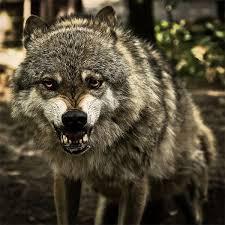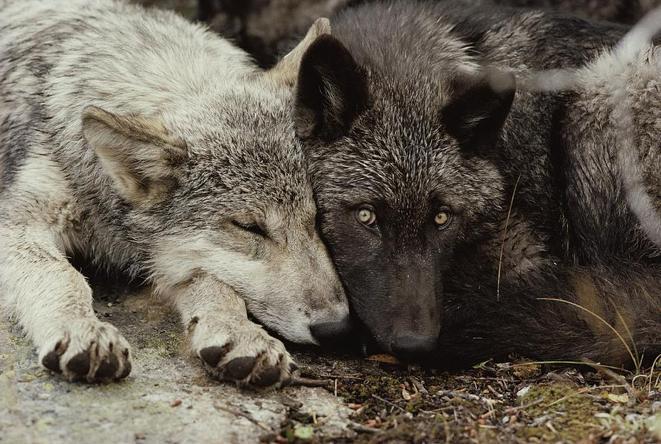The first image is the image on the left, the second image is the image on the right. Evaluate the accuracy of this statement regarding the images: "There is at least two wolves in the left image.". Is it true? Answer yes or no. No. The first image is the image on the left, the second image is the image on the right. Given the left and right images, does the statement "A camera-facing wolf has fangs bared in a fierce expression." hold true? Answer yes or no. Yes. 